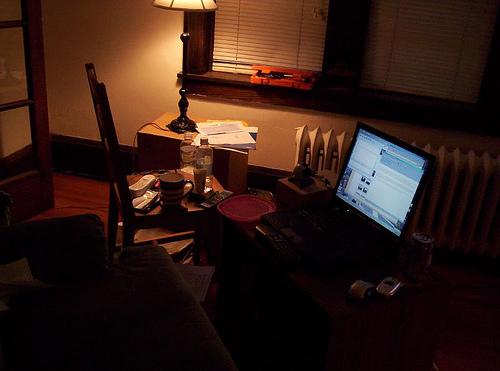What is on the screen?
Concise answer only. Chat window. What operating system does the computer have?
Concise answer only. Windows. Is the room dark?
Concise answer only. Yes. 